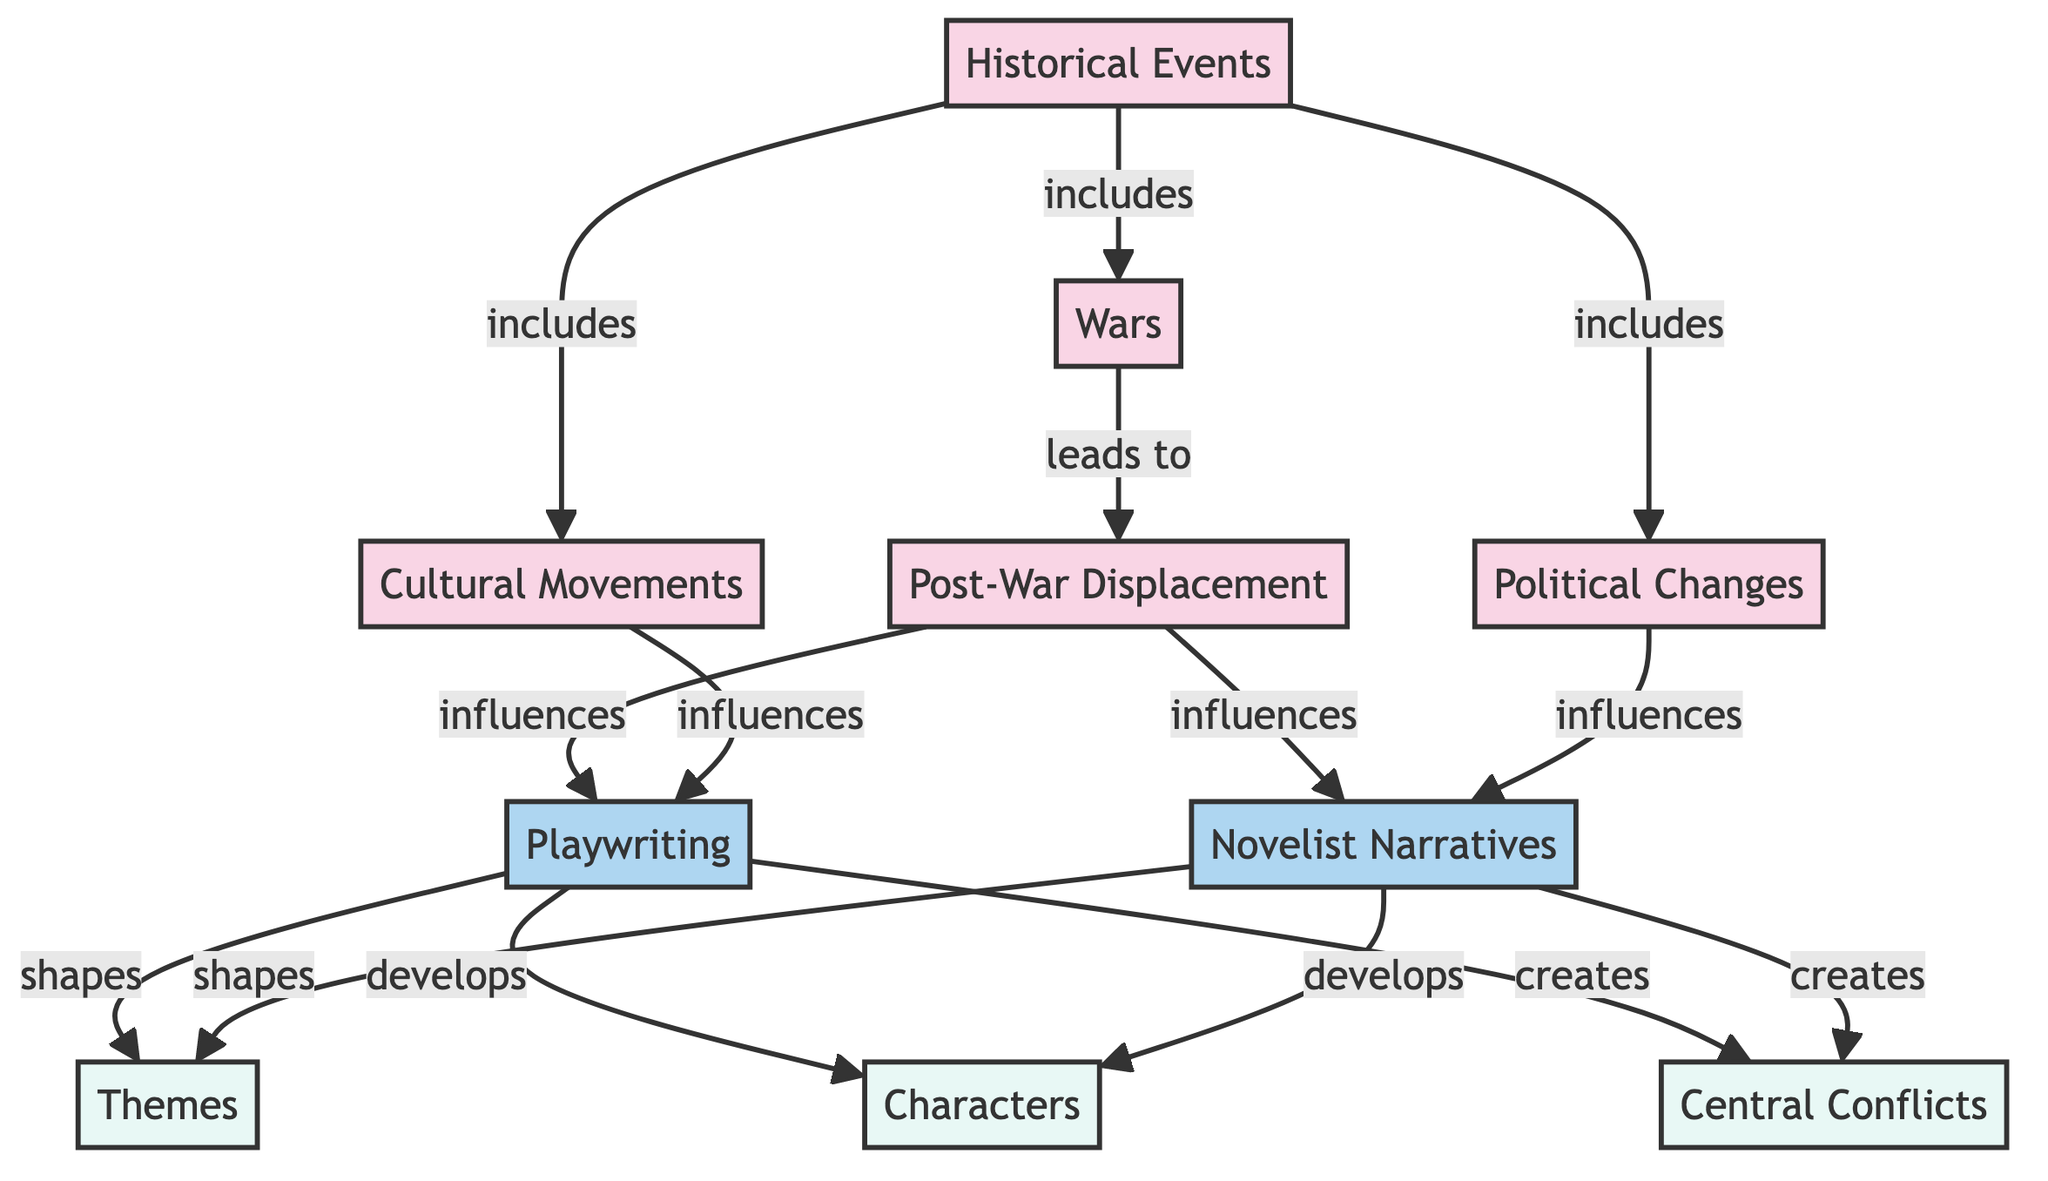What are examples of historical events in this diagram? The diagram lists "Wars," "Cultural Movements," and "Political Changes" as examples of historical events, so the answer requires looking at the nodes connected to the "Historical Events" node.
Answer: Wars, Cultural Movements, Political Changes How many types of historical events are represented? The diagram connects "Historical Events" to three specific types: Wars, Cultural Movements, and Political Changes, therefore counting these gives the total number of types represented.
Answer: 3 Which historical event leads to post-war displacement? The diagram directly connects "Wars" to "Post-War Displacement," indicating that wars are a precursor to post-war displacement in the sequence.
Answer: Wars What influences playwriting in the diagram? The diagram shows that "Post-War Displacement" and "Cultural Movements" both influence "Playwriting," requiring the identification of these two connections from the respective nodes.
Answer: Post-War Displacement, Cultural Movements How many output elements are shaped by playwriting? The diagram indicates that "Playwriting" shapes "Themes," "Characters," and "Central Conflicts," which are three specific elements identified as outputs, hence the number can be counted directly.
Answer: 3 What relationship exists between post-war displacement and novelist narratives? The diagram shows that "Post-War Displacement" influences "Novelist Narratives," indicating a direct influence relationship that needs to be noted from the connected nodes.
Answer: influences Which elements are developed by novelist narratives? According to the diagram, "Novelist Narratives" develops "Themes" and "Characters," thus identifying these two specific outputs associated with the novelist's narratives leads to the answer.
Answer: Themes, Characters What commonalities exist between playwriting and novelist narratives in terms of output? Both "Playwriting" and "Novelist Narratives" contribute to shaping "Themes," "Characters," and "Central Conflicts," which highlights their influences on similar output elements.
Answer: Themes, Characters, Central Conflicts Identify a direct influence on themes from historical events. "Cultural Movements" directly influences "Themes," as shown in the diagram, making it necessary to trace this connection from cultural movements to the theme node for clarity.
Answer: Cultural Movements 